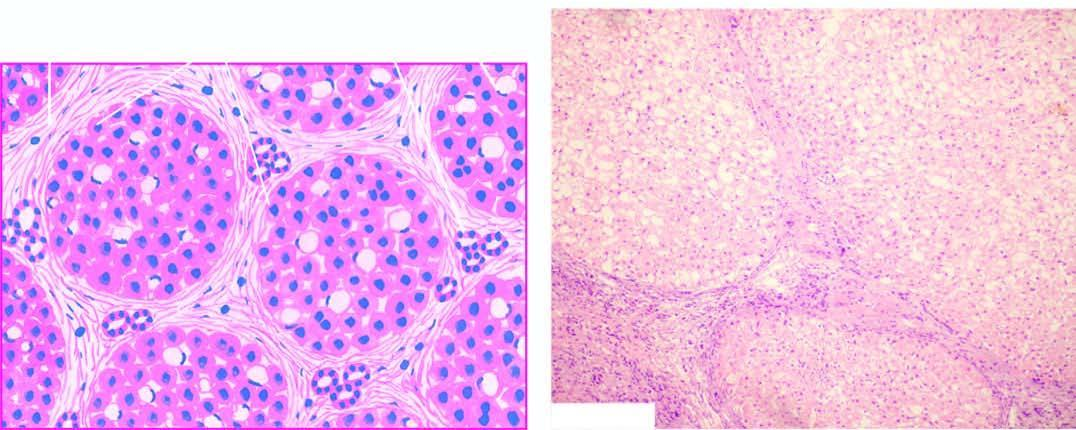where is minimal inflammation and some reactive bile duct proliferation?
Answer the question using a single word or phrase. In the septa 